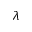Convert formula to latex. <formula><loc_0><loc_0><loc_500><loc_500>\lambda</formula> 